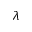Convert formula to latex. <formula><loc_0><loc_0><loc_500><loc_500>\lambda</formula> 